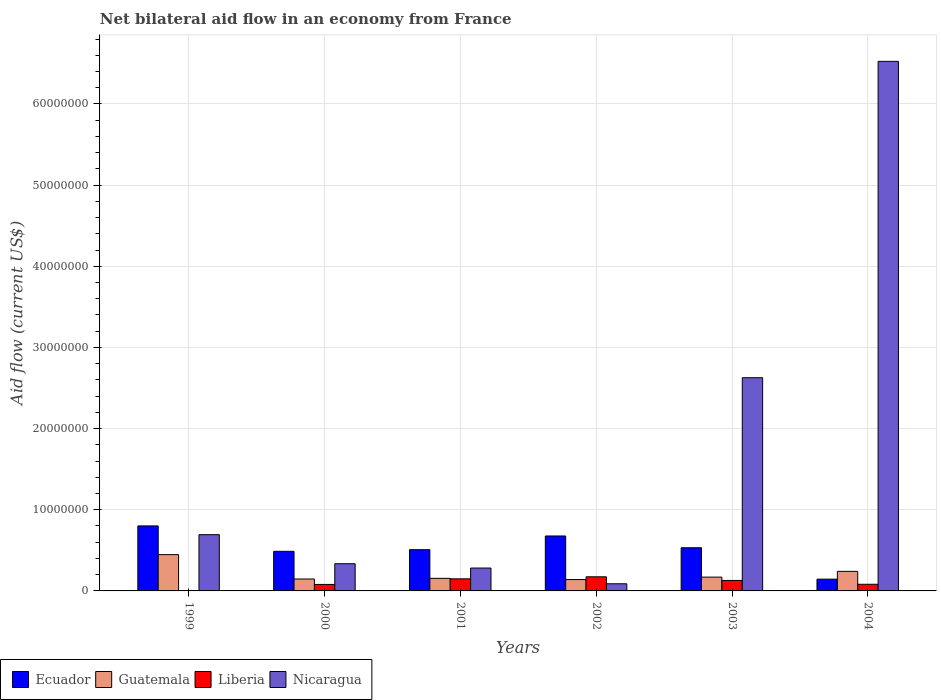How many groups of bars are there?
Your answer should be very brief. 6. Are the number of bars per tick equal to the number of legend labels?
Provide a succinct answer. Yes. In how many cases, is the number of bars for a given year not equal to the number of legend labels?
Give a very brief answer. 0. What is the net bilateral aid flow in Nicaragua in 2004?
Ensure brevity in your answer.  6.52e+07. Across all years, what is the maximum net bilateral aid flow in Ecuador?
Give a very brief answer. 8.01e+06. Across all years, what is the minimum net bilateral aid flow in Guatemala?
Keep it short and to the point. 1.40e+06. In which year was the net bilateral aid flow in Ecuador minimum?
Offer a very short reply. 2004. What is the total net bilateral aid flow in Guatemala in the graph?
Ensure brevity in your answer.  1.30e+07. What is the difference between the net bilateral aid flow in Ecuador in 2000 and that in 2003?
Your response must be concise. -4.40e+05. What is the difference between the net bilateral aid flow in Liberia in 2003 and the net bilateral aid flow in Ecuador in 2004?
Offer a very short reply. -1.60e+05. What is the average net bilateral aid flow in Ecuador per year?
Offer a terse response. 5.25e+06. What is the ratio of the net bilateral aid flow in Ecuador in 2001 to that in 2003?
Your answer should be very brief. 0.95. What is the difference between the highest and the second highest net bilateral aid flow in Guatemala?
Keep it short and to the point. 2.06e+06. What is the difference between the highest and the lowest net bilateral aid flow in Ecuador?
Your response must be concise. 6.56e+06. Is the sum of the net bilateral aid flow in Ecuador in 1999 and 2002 greater than the maximum net bilateral aid flow in Nicaragua across all years?
Your response must be concise. No. Is it the case that in every year, the sum of the net bilateral aid flow in Guatemala and net bilateral aid flow in Ecuador is greater than the sum of net bilateral aid flow in Liberia and net bilateral aid flow in Nicaragua?
Give a very brief answer. Yes. What does the 2nd bar from the left in 2003 represents?
Offer a very short reply. Guatemala. What does the 3rd bar from the right in 2003 represents?
Provide a short and direct response. Guatemala. Is it the case that in every year, the sum of the net bilateral aid flow in Nicaragua and net bilateral aid flow in Liberia is greater than the net bilateral aid flow in Ecuador?
Provide a short and direct response. No. How many bars are there?
Provide a succinct answer. 24. Are all the bars in the graph horizontal?
Make the answer very short. No. How many years are there in the graph?
Offer a very short reply. 6. What is the difference between two consecutive major ticks on the Y-axis?
Your answer should be very brief. 1.00e+07. Does the graph contain grids?
Offer a terse response. Yes. How are the legend labels stacked?
Offer a terse response. Horizontal. What is the title of the graph?
Keep it short and to the point. Net bilateral aid flow in an economy from France. What is the label or title of the Y-axis?
Keep it short and to the point. Aid flow (current US$). What is the Aid flow (current US$) of Ecuador in 1999?
Offer a very short reply. 8.01e+06. What is the Aid flow (current US$) in Guatemala in 1999?
Keep it short and to the point. 4.47e+06. What is the Aid flow (current US$) in Nicaragua in 1999?
Give a very brief answer. 6.93e+06. What is the Aid flow (current US$) in Ecuador in 2000?
Offer a terse response. 4.88e+06. What is the Aid flow (current US$) of Guatemala in 2000?
Your answer should be compact. 1.47e+06. What is the Aid flow (current US$) of Liberia in 2000?
Make the answer very short. 8.00e+05. What is the Aid flow (current US$) in Nicaragua in 2000?
Make the answer very short. 3.35e+06. What is the Aid flow (current US$) of Ecuador in 2001?
Make the answer very short. 5.08e+06. What is the Aid flow (current US$) of Guatemala in 2001?
Your answer should be very brief. 1.55e+06. What is the Aid flow (current US$) in Liberia in 2001?
Offer a very short reply. 1.49e+06. What is the Aid flow (current US$) in Nicaragua in 2001?
Give a very brief answer. 2.82e+06. What is the Aid flow (current US$) of Ecuador in 2002?
Ensure brevity in your answer.  6.77e+06. What is the Aid flow (current US$) in Guatemala in 2002?
Ensure brevity in your answer.  1.40e+06. What is the Aid flow (current US$) in Liberia in 2002?
Make the answer very short. 1.74e+06. What is the Aid flow (current US$) of Nicaragua in 2002?
Ensure brevity in your answer.  8.80e+05. What is the Aid flow (current US$) of Ecuador in 2003?
Ensure brevity in your answer.  5.32e+06. What is the Aid flow (current US$) in Guatemala in 2003?
Provide a short and direct response. 1.70e+06. What is the Aid flow (current US$) of Liberia in 2003?
Keep it short and to the point. 1.29e+06. What is the Aid flow (current US$) in Nicaragua in 2003?
Your answer should be compact. 2.63e+07. What is the Aid flow (current US$) in Ecuador in 2004?
Make the answer very short. 1.45e+06. What is the Aid flow (current US$) in Guatemala in 2004?
Offer a terse response. 2.41e+06. What is the Aid flow (current US$) in Liberia in 2004?
Your answer should be compact. 8.20e+05. What is the Aid flow (current US$) of Nicaragua in 2004?
Provide a succinct answer. 6.52e+07. Across all years, what is the maximum Aid flow (current US$) of Ecuador?
Offer a terse response. 8.01e+06. Across all years, what is the maximum Aid flow (current US$) of Guatemala?
Provide a succinct answer. 4.47e+06. Across all years, what is the maximum Aid flow (current US$) in Liberia?
Your answer should be very brief. 1.74e+06. Across all years, what is the maximum Aid flow (current US$) in Nicaragua?
Your response must be concise. 6.52e+07. Across all years, what is the minimum Aid flow (current US$) of Ecuador?
Ensure brevity in your answer.  1.45e+06. Across all years, what is the minimum Aid flow (current US$) in Guatemala?
Keep it short and to the point. 1.40e+06. Across all years, what is the minimum Aid flow (current US$) of Nicaragua?
Ensure brevity in your answer.  8.80e+05. What is the total Aid flow (current US$) in Ecuador in the graph?
Your response must be concise. 3.15e+07. What is the total Aid flow (current US$) of Guatemala in the graph?
Offer a very short reply. 1.30e+07. What is the total Aid flow (current US$) in Liberia in the graph?
Make the answer very short. 6.17e+06. What is the total Aid flow (current US$) in Nicaragua in the graph?
Ensure brevity in your answer.  1.06e+08. What is the difference between the Aid flow (current US$) in Ecuador in 1999 and that in 2000?
Keep it short and to the point. 3.13e+06. What is the difference between the Aid flow (current US$) in Guatemala in 1999 and that in 2000?
Give a very brief answer. 3.00e+06. What is the difference between the Aid flow (current US$) in Liberia in 1999 and that in 2000?
Give a very brief answer. -7.70e+05. What is the difference between the Aid flow (current US$) in Nicaragua in 1999 and that in 2000?
Your response must be concise. 3.58e+06. What is the difference between the Aid flow (current US$) in Ecuador in 1999 and that in 2001?
Offer a terse response. 2.93e+06. What is the difference between the Aid flow (current US$) in Guatemala in 1999 and that in 2001?
Your answer should be compact. 2.92e+06. What is the difference between the Aid flow (current US$) in Liberia in 1999 and that in 2001?
Your answer should be compact. -1.46e+06. What is the difference between the Aid flow (current US$) in Nicaragua in 1999 and that in 2001?
Offer a terse response. 4.11e+06. What is the difference between the Aid flow (current US$) in Ecuador in 1999 and that in 2002?
Give a very brief answer. 1.24e+06. What is the difference between the Aid flow (current US$) in Guatemala in 1999 and that in 2002?
Keep it short and to the point. 3.07e+06. What is the difference between the Aid flow (current US$) in Liberia in 1999 and that in 2002?
Keep it short and to the point. -1.71e+06. What is the difference between the Aid flow (current US$) in Nicaragua in 1999 and that in 2002?
Provide a succinct answer. 6.05e+06. What is the difference between the Aid flow (current US$) in Ecuador in 1999 and that in 2003?
Offer a terse response. 2.69e+06. What is the difference between the Aid flow (current US$) of Guatemala in 1999 and that in 2003?
Provide a succinct answer. 2.77e+06. What is the difference between the Aid flow (current US$) of Liberia in 1999 and that in 2003?
Ensure brevity in your answer.  -1.26e+06. What is the difference between the Aid flow (current US$) in Nicaragua in 1999 and that in 2003?
Your response must be concise. -1.93e+07. What is the difference between the Aid flow (current US$) of Ecuador in 1999 and that in 2004?
Provide a succinct answer. 6.56e+06. What is the difference between the Aid flow (current US$) of Guatemala in 1999 and that in 2004?
Keep it short and to the point. 2.06e+06. What is the difference between the Aid flow (current US$) in Liberia in 1999 and that in 2004?
Keep it short and to the point. -7.90e+05. What is the difference between the Aid flow (current US$) of Nicaragua in 1999 and that in 2004?
Offer a terse response. -5.83e+07. What is the difference between the Aid flow (current US$) of Guatemala in 2000 and that in 2001?
Offer a very short reply. -8.00e+04. What is the difference between the Aid flow (current US$) in Liberia in 2000 and that in 2001?
Ensure brevity in your answer.  -6.90e+05. What is the difference between the Aid flow (current US$) of Nicaragua in 2000 and that in 2001?
Offer a terse response. 5.30e+05. What is the difference between the Aid flow (current US$) of Ecuador in 2000 and that in 2002?
Ensure brevity in your answer.  -1.89e+06. What is the difference between the Aid flow (current US$) in Guatemala in 2000 and that in 2002?
Ensure brevity in your answer.  7.00e+04. What is the difference between the Aid flow (current US$) of Liberia in 2000 and that in 2002?
Make the answer very short. -9.40e+05. What is the difference between the Aid flow (current US$) of Nicaragua in 2000 and that in 2002?
Your response must be concise. 2.47e+06. What is the difference between the Aid flow (current US$) of Ecuador in 2000 and that in 2003?
Provide a succinct answer. -4.40e+05. What is the difference between the Aid flow (current US$) in Liberia in 2000 and that in 2003?
Keep it short and to the point. -4.90e+05. What is the difference between the Aid flow (current US$) in Nicaragua in 2000 and that in 2003?
Offer a very short reply. -2.29e+07. What is the difference between the Aid flow (current US$) in Ecuador in 2000 and that in 2004?
Your response must be concise. 3.43e+06. What is the difference between the Aid flow (current US$) in Guatemala in 2000 and that in 2004?
Your answer should be very brief. -9.40e+05. What is the difference between the Aid flow (current US$) in Nicaragua in 2000 and that in 2004?
Keep it short and to the point. -6.19e+07. What is the difference between the Aid flow (current US$) in Ecuador in 2001 and that in 2002?
Provide a succinct answer. -1.69e+06. What is the difference between the Aid flow (current US$) in Guatemala in 2001 and that in 2002?
Provide a succinct answer. 1.50e+05. What is the difference between the Aid flow (current US$) of Liberia in 2001 and that in 2002?
Provide a succinct answer. -2.50e+05. What is the difference between the Aid flow (current US$) of Nicaragua in 2001 and that in 2002?
Keep it short and to the point. 1.94e+06. What is the difference between the Aid flow (current US$) in Nicaragua in 2001 and that in 2003?
Offer a terse response. -2.34e+07. What is the difference between the Aid flow (current US$) of Ecuador in 2001 and that in 2004?
Give a very brief answer. 3.63e+06. What is the difference between the Aid flow (current US$) of Guatemala in 2001 and that in 2004?
Offer a terse response. -8.60e+05. What is the difference between the Aid flow (current US$) of Liberia in 2001 and that in 2004?
Your answer should be very brief. 6.70e+05. What is the difference between the Aid flow (current US$) of Nicaragua in 2001 and that in 2004?
Your response must be concise. -6.24e+07. What is the difference between the Aid flow (current US$) of Ecuador in 2002 and that in 2003?
Your response must be concise. 1.45e+06. What is the difference between the Aid flow (current US$) of Nicaragua in 2002 and that in 2003?
Provide a succinct answer. -2.54e+07. What is the difference between the Aid flow (current US$) of Ecuador in 2002 and that in 2004?
Keep it short and to the point. 5.32e+06. What is the difference between the Aid flow (current US$) of Guatemala in 2002 and that in 2004?
Provide a short and direct response. -1.01e+06. What is the difference between the Aid flow (current US$) in Liberia in 2002 and that in 2004?
Make the answer very short. 9.20e+05. What is the difference between the Aid flow (current US$) in Nicaragua in 2002 and that in 2004?
Your answer should be very brief. -6.44e+07. What is the difference between the Aid flow (current US$) of Ecuador in 2003 and that in 2004?
Give a very brief answer. 3.87e+06. What is the difference between the Aid flow (current US$) in Guatemala in 2003 and that in 2004?
Ensure brevity in your answer.  -7.10e+05. What is the difference between the Aid flow (current US$) in Liberia in 2003 and that in 2004?
Keep it short and to the point. 4.70e+05. What is the difference between the Aid flow (current US$) in Nicaragua in 2003 and that in 2004?
Your answer should be very brief. -3.90e+07. What is the difference between the Aid flow (current US$) in Ecuador in 1999 and the Aid flow (current US$) in Guatemala in 2000?
Your response must be concise. 6.54e+06. What is the difference between the Aid flow (current US$) of Ecuador in 1999 and the Aid flow (current US$) of Liberia in 2000?
Offer a terse response. 7.21e+06. What is the difference between the Aid flow (current US$) of Ecuador in 1999 and the Aid flow (current US$) of Nicaragua in 2000?
Ensure brevity in your answer.  4.66e+06. What is the difference between the Aid flow (current US$) in Guatemala in 1999 and the Aid flow (current US$) in Liberia in 2000?
Your answer should be very brief. 3.67e+06. What is the difference between the Aid flow (current US$) of Guatemala in 1999 and the Aid flow (current US$) of Nicaragua in 2000?
Provide a succinct answer. 1.12e+06. What is the difference between the Aid flow (current US$) of Liberia in 1999 and the Aid flow (current US$) of Nicaragua in 2000?
Keep it short and to the point. -3.32e+06. What is the difference between the Aid flow (current US$) in Ecuador in 1999 and the Aid flow (current US$) in Guatemala in 2001?
Offer a terse response. 6.46e+06. What is the difference between the Aid flow (current US$) of Ecuador in 1999 and the Aid flow (current US$) of Liberia in 2001?
Keep it short and to the point. 6.52e+06. What is the difference between the Aid flow (current US$) in Ecuador in 1999 and the Aid flow (current US$) in Nicaragua in 2001?
Ensure brevity in your answer.  5.19e+06. What is the difference between the Aid flow (current US$) of Guatemala in 1999 and the Aid flow (current US$) of Liberia in 2001?
Give a very brief answer. 2.98e+06. What is the difference between the Aid flow (current US$) of Guatemala in 1999 and the Aid flow (current US$) of Nicaragua in 2001?
Offer a terse response. 1.65e+06. What is the difference between the Aid flow (current US$) in Liberia in 1999 and the Aid flow (current US$) in Nicaragua in 2001?
Your answer should be very brief. -2.79e+06. What is the difference between the Aid flow (current US$) of Ecuador in 1999 and the Aid flow (current US$) of Guatemala in 2002?
Make the answer very short. 6.61e+06. What is the difference between the Aid flow (current US$) in Ecuador in 1999 and the Aid flow (current US$) in Liberia in 2002?
Provide a short and direct response. 6.27e+06. What is the difference between the Aid flow (current US$) in Ecuador in 1999 and the Aid flow (current US$) in Nicaragua in 2002?
Give a very brief answer. 7.13e+06. What is the difference between the Aid flow (current US$) of Guatemala in 1999 and the Aid flow (current US$) of Liberia in 2002?
Provide a short and direct response. 2.73e+06. What is the difference between the Aid flow (current US$) in Guatemala in 1999 and the Aid flow (current US$) in Nicaragua in 2002?
Make the answer very short. 3.59e+06. What is the difference between the Aid flow (current US$) in Liberia in 1999 and the Aid flow (current US$) in Nicaragua in 2002?
Make the answer very short. -8.50e+05. What is the difference between the Aid flow (current US$) in Ecuador in 1999 and the Aid flow (current US$) in Guatemala in 2003?
Give a very brief answer. 6.31e+06. What is the difference between the Aid flow (current US$) in Ecuador in 1999 and the Aid flow (current US$) in Liberia in 2003?
Give a very brief answer. 6.72e+06. What is the difference between the Aid flow (current US$) of Ecuador in 1999 and the Aid flow (current US$) of Nicaragua in 2003?
Ensure brevity in your answer.  -1.83e+07. What is the difference between the Aid flow (current US$) in Guatemala in 1999 and the Aid flow (current US$) in Liberia in 2003?
Provide a succinct answer. 3.18e+06. What is the difference between the Aid flow (current US$) of Guatemala in 1999 and the Aid flow (current US$) of Nicaragua in 2003?
Your response must be concise. -2.18e+07. What is the difference between the Aid flow (current US$) in Liberia in 1999 and the Aid flow (current US$) in Nicaragua in 2003?
Offer a very short reply. -2.62e+07. What is the difference between the Aid flow (current US$) in Ecuador in 1999 and the Aid flow (current US$) in Guatemala in 2004?
Offer a very short reply. 5.60e+06. What is the difference between the Aid flow (current US$) in Ecuador in 1999 and the Aid flow (current US$) in Liberia in 2004?
Your response must be concise. 7.19e+06. What is the difference between the Aid flow (current US$) of Ecuador in 1999 and the Aid flow (current US$) of Nicaragua in 2004?
Ensure brevity in your answer.  -5.72e+07. What is the difference between the Aid flow (current US$) in Guatemala in 1999 and the Aid flow (current US$) in Liberia in 2004?
Ensure brevity in your answer.  3.65e+06. What is the difference between the Aid flow (current US$) in Guatemala in 1999 and the Aid flow (current US$) in Nicaragua in 2004?
Ensure brevity in your answer.  -6.08e+07. What is the difference between the Aid flow (current US$) of Liberia in 1999 and the Aid flow (current US$) of Nicaragua in 2004?
Provide a short and direct response. -6.52e+07. What is the difference between the Aid flow (current US$) of Ecuador in 2000 and the Aid flow (current US$) of Guatemala in 2001?
Your response must be concise. 3.33e+06. What is the difference between the Aid flow (current US$) of Ecuador in 2000 and the Aid flow (current US$) of Liberia in 2001?
Provide a short and direct response. 3.39e+06. What is the difference between the Aid flow (current US$) of Ecuador in 2000 and the Aid flow (current US$) of Nicaragua in 2001?
Make the answer very short. 2.06e+06. What is the difference between the Aid flow (current US$) in Guatemala in 2000 and the Aid flow (current US$) in Liberia in 2001?
Provide a short and direct response. -2.00e+04. What is the difference between the Aid flow (current US$) of Guatemala in 2000 and the Aid flow (current US$) of Nicaragua in 2001?
Provide a succinct answer. -1.35e+06. What is the difference between the Aid flow (current US$) of Liberia in 2000 and the Aid flow (current US$) of Nicaragua in 2001?
Provide a short and direct response. -2.02e+06. What is the difference between the Aid flow (current US$) in Ecuador in 2000 and the Aid flow (current US$) in Guatemala in 2002?
Your answer should be compact. 3.48e+06. What is the difference between the Aid flow (current US$) of Ecuador in 2000 and the Aid flow (current US$) of Liberia in 2002?
Offer a terse response. 3.14e+06. What is the difference between the Aid flow (current US$) in Ecuador in 2000 and the Aid flow (current US$) in Nicaragua in 2002?
Your answer should be compact. 4.00e+06. What is the difference between the Aid flow (current US$) of Guatemala in 2000 and the Aid flow (current US$) of Nicaragua in 2002?
Give a very brief answer. 5.90e+05. What is the difference between the Aid flow (current US$) of Ecuador in 2000 and the Aid flow (current US$) of Guatemala in 2003?
Provide a succinct answer. 3.18e+06. What is the difference between the Aid flow (current US$) of Ecuador in 2000 and the Aid flow (current US$) of Liberia in 2003?
Your answer should be very brief. 3.59e+06. What is the difference between the Aid flow (current US$) of Ecuador in 2000 and the Aid flow (current US$) of Nicaragua in 2003?
Ensure brevity in your answer.  -2.14e+07. What is the difference between the Aid flow (current US$) in Guatemala in 2000 and the Aid flow (current US$) in Nicaragua in 2003?
Keep it short and to the point. -2.48e+07. What is the difference between the Aid flow (current US$) of Liberia in 2000 and the Aid flow (current US$) of Nicaragua in 2003?
Your response must be concise. -2.55e+07. What is the difference between the Aid flow (current US$) in Ecuador in 2000 and the Aid flow (current US$) in Guatemala in 2004?
Keep it short and to the point. 2.47e+06. What is the difference between the Aid flow (current US$) of Ecuador in 2000 and the Aid flow (current US$) of Liberia in 2004?
Make the answer very short. 4.06e+06. What is the difference between the Aid flow (current US$) in Ecuador in 2000 and the Aid flow (current US$) in Nicaragua in 2004?
Offer a terse response. -6.04e+07. What is the difference between the Aid flow (current US$) of Guatemala in 2000 and the Aid flow (current US$) of Liberia in 2004?
Make the answer very short. 6.50e+05. What is the difference between the Aid flow (current US$) in Guatemala in 2000 and the Aid flow (current US$) in Nicaragua in 2004?
Ensure brevity in your answer.  -6.38e+07. What is the difference between the Aid flow (current US$) of Liberia in 2000 and the Aid flow (current US$) of Nicaragua in 2004?
Your answer should be very brief. -6.44e+07. What is the difference between the Aid flow (current US$) of Ecuador in 2001 and the Aid flow (current US$) of Guatemala in 2002?
Offer a terse response. 3.68e+06. What is the difference between the Aid flow (current US$) in Ecuador in 2001 and the Aid flow (current US$) in Liberia in 2002?
Keep it short and to the point. 3.34e+06. What is the difference between the Aid flow (current US$) of Ecuador in 2001 and the Aid flow (current US$) of Nicaragua in 2002?
Your answer should be very brief. 4.20e+06. What is the difference between the Aid flow (current US$) in Guatemala in 2001 and the Aid flow (current US$) in Nicaragua in 2002?
Give a very brief answer. 6.70e+05. What is the difference between the Aid flow (current US$) in Ecuador in 2001 and the Aid flow (current US$) in Guatemala in 2003?
Provide a short and direct response. 3.38e+06. What is the difference between the Aid flow (current US$) in Ecuador in 2001 and the Aid flow (current US$) in Liberia in 2003?
Offer a terse response. 3.79e+06. What is the difference between the Aid flow (current US$) in Ecuador in 2001 and the Aid flow (current US$) in Nicaragua in 2003?
Your answer should be compact. -2.12e+07. What is the difference between the Aid flow (current US$) of Guatemala in 2001 and the Aid flow (current US$) of Liberia in 2003?
Offer a terse response. 2.60e+05. What is the difference between the Aid flow (current US$) of Guatemala in 2001 and the Aid flow (current US$) of Nicaragua in 2003?
Provide a succinct answer. -2.47e+07. What is the difference between the Aid flow (current US$) of Liberia in 2001 and the Aid flow (current US$) of Nicaragua in 2003?
Your answer should be very brief. -2.48e+07. What is the difference between the Aid flow (current US$) of Ecuador in 2001 and the Aid flow (current US$) of Guatemala in 2004?
Give a very brief answer. 2.67e+06. What is the difference between the Aid flow (current US$) of Ecuador in 2001 and the Aid flow (current US$) of Liberia in 2004?
Ensure brevity in your answer.  4.26e+06. What is the difference between the Aid flow (current US$) of Ecuador in 2001 and the Aid flow (current US$) of Nicaragua in 2004?
Give a very brief answer. -6.02e+07. What is the difference between the Aid flow (current US$) in Guatemala in 2001 and the Aid flow (current US$) in Liberia in 2004?
Provide a short and direct response. 7.30e+05. What is the difference between the Aid flow (current US$) of Guatemala in 2001 and the Aid flow (current US$) of Nicaragua in 2004?
Make the answer very short. -6.37e+07. What is the difference between the Aid flow (current US$) in Liberia in 2001 and the Aid flow (current US$) in Nicaragua in 2004?
Provide a short and direct response. -6.38e+07. What is the difference between the Aid flow (current US$) of Ecuador in 2002 and the Aid flow (current US$) of Guatemala in 2003?
Your answer should be very brief. 5.07e+06. What is the difference between the Aid flow (current US$) in Ecuador in 2002 and the Aid flow (current US$) in Liberia in 2003?
Make the answer very short. 5.48e+06. What is the difference between the Aid flow (current US$) of Ecuador in 2002 and the Aid flow (current US$) of Nicaragua in 2003?
Your response must be concise. -1.95e+07. What is the difference between the Aid flow (current US$) of Guatemala in 2002 and the Aid flow (current US$) of Liberia in 2003?
Give a very brief answer. 1.10e+05. What is the difference between the Aid flow (current US$) in Guatemala in 2002 and the Aid flow (current US$) in Nicaragua in 2003?
Your answer should be very brief. -2.49e+07. What is the difference between the Aid flow (current US$) in Liberia in 2002 and the Aid flow (current US$) in Nicaragua in 2003?
Offer a very short reply. -2.45e+07. What is the difference between the Aid flow (current US$) of Ecuador in 2002 and the Aid flow (current US$) of Guatemala in 2004?
Your answer should be very brief. 4.36e+06. What is the difference between the Aid flow (current US$) in Ecuador in 2002 and the Aid flow (current US$) in Liberia in 2004?
Give a very brief answer. 5.95e+06. What is the difference between the Aid flow (current US$) in Ecuador in 2002 and the Aid flow (current US$) in Nicaragua in 2004?
Offer a very short reply. -5.85e+07. What is the difference between the Aid flow (current US$) in Guatemala in 2002 and the Aid flow (current US$) in Liberia in 2004?
Provide a succinct answer. 5.80e+05. What is the difference between the Aid flow (current US$) of Guatemala in 2002 and the Aid flow (current US$) of Nicaragua in 2004?
Your answer should be compact. -6.38e+07. What is the difference between the Aid flow (current US$) of Liberia in 2002 and the Aid flow (current US$) of Nicaragua in 2004?
Offer a terse response. -6.35e+07. What is the difference between the Aid flow (current US$) in Ecuador in 2003 and the Aid flow (current US$) in Guatemala in 2004?
Make the answer very short. 2.91e+06. What is the difference between the Aid flow (current US$) in Ecuador in 2003 and the Aid flow (current US$) in Liberia in 2004?
Give a very brief answer. 4.50e+06. What is the difference between the Aid flow (current US$) in Ecuador in 2003 and the Aid flow (current US$) in Nicaragua in 2004?
Your answer should be very brief. -5.99e+07. What is the difference between the Aid flow (current US$) of Guatemala in 2003 and the Aid flow (current US$) of Liberia in 2004?
Offer a very short reply. 8.80e+05. What is the difference between the Aid flow (current US$) in Guatemala in 2003 and the Aid flow (current US$) in Nicaragua in 2004?
Provide a succinct answer. -6.36e+07. What is the difference between the Aid flow (current US$) in Liberia in 2003 and the Aid flow (current US$) in Nicaragua in 2004?
Ensure brevity in your answer.  -6.40e+07. What is the average Aid flow (current US$) of Ecuador per year?
Keep it short and to the point. 5.25e+06. What is the average Aid flow (current US$) in Guatemala per year?
Offer a very short reply. 2.17e+06. What is the average Aid flow (current US$) in Liberia per year?
Your response must be concise. 1.03e+06. What is the average Aid flow (current US$) of Nicaragua per year?
Provide a short and direct response. 1.76e+07. In the year 1999, what is the difference between the Aid flow (current US$) of Ecuador and Aid flow (current US$) of Guatemala?
Ensure brevity in your answer.  3.54e+06. In the year 1999, what is the difference between the Aid flow (current US$) of Ecuador and Aid flow (current US$) of Liberia?
Provide a succinct answer. 7.98e+06. In the year 1999, what is the difference between the Aid flow (current US$) of Ecuador and Aid flow (current US$) of Nicaragua?
Offer a very short reply. 1.08e+06. In the year 1999, what is the difference between the Aid flow (current US$) in Guatemala and Aid flow (current US$) in Liberia?
Your response must be concise. 4.44e+06. In the year 1999, what is the difference between the Aid flow (current US$) in Guatemala and Aid flow (current US$) in Nicaragua?
Offer a terse response. -2.46e+06. In the year 1999, what is the difference between the Aid flow (current US$) in Liberia and Aid flow (current US$) in Nicaragua?
Make the answer very short. -6.90e+06. In the year 2000, what is the difference between the Aid flow (current US$) of Ecuador and Aid flow (current US$) of Guatemala?
Keep it short and to the point. 3.41e+06. In the year 2000, what is the difference between the Aid flow (current US$) of Ecuador and Aid flow (current US$) of Liberia?
Provide a succinct answer. 4.08e+06. In the year 2000, what is the difference between the Aid flow (current US$) of Ecuador and Aid flow (current US$) of Nicaragua?
Offer a terse response. 1.53e+06. In the year 2000, what is the difference between the Aid flow (current US$) in Guatemala and Aid flow (current US$) in Liberia?
Ensure brevity in your answer.  6.70e+05. In the year 2000, what is the difference between the Aid flow (current US$) in Guatemala and Aid flow (current US$) in Nicaragua?
Keep it short and to the point. -1.88e+06. In the year 2000, what is the difference between the Aid flow (current US$) of Liberia and Aid flow (current US$) of Nicaragua?
Your response must be concise. -2.55e+06. In the year 2001, what is the difference between the Aid flow (current US$) in Ecuador and Aid flow (current US$) in Guatemala?
Your answer should be very brief. 3.53e+06. In the year 2001, what is the difference between the Aid flow (current US$) in Ecuador and Aid flow (current US$) in Liberia?
Keep it short and to the point. 3.59e+06. In the year 2001, what is the difference between the Aid flow (current US$) in Ecuador and Aid flow (current US$) in Nicaragua?
Make the answer very short. 2.26e+06. In the year 2001, what is the difference between the Aid flow (current US$) in Guatemala and Aid flow (current US$) in Nicaragua?
Your answer should be very brief. -1.27e+06. In the year 2001, what is the difference between the Aid flow (current US$) in Liberia and Aid flow (current US$) in Nicaragua?
Your answer should be compact. -1.33e+06. In the year 2002, what is the difference between the Aid flow (current US$) of Ecuador and Aid flow (current US$) of Guatemala?
Offer a terse response. 5.37e+06. In the year 2002, what is the difference between the Aid flow (current US$) in Ecuador and Aid flow (current US$) in Liberia?
Make the answer very short. 5.03e+06. In the year 2002, what is the difference between the Aid flow (current US$) in Ecuador and Aid flow (current US$) in Nicaragua?
Give a very brief answer. 5.89e+06. In the year 2002, what is the difference between the Aid flow (current US$) in Guatemala and Aid flow (current US$) in Liberia?
Ensure brevity in your answer.  -3.40e+05. In the year 2002, what is the difference between the Aid flow (current US$) in Guatemala and Aid flow (current US$) in Nicaragua?
Provide a short and direct response. 5.20e+05. In the year 2002, what is the difference between the Aid flow (current US$) in Liberia and Aid flow (current US$) in Nicaragua?
Provide a short and direct response. 8.60e+05. In the year 2003, what is the difference between the Aid flow (current US$) in Ecuador and Aid flow (current US$) in Guatemala?
Your response must be concise. 3.62e+06. In the year 2003, what is the difference between the Aid flow (current US$) in Ecuador and Aid flow (current US$) in Liberia?
Offer a terse response. 4.03e+06. In the year 2003, what is the difference between the Aid flow (current US$) of Ecuador and Aid flow (current US$) of Nicaragua?
Your answer should be compact. -2.10e+07. In the year 2003, what is the difference between the Aid flow (current US$) in Guatemala and Aid flow (current US$) in Nicaragua?
Ensure brevity in your answer.  -2.46e+07. In the year 2003, what is the difference between the Aid flow (current US$) of Liberia and Aid flow (current US$) of Nicaragua?
Your answer should be very brief. -2.50e+07. In the year 2004, what is the difference between the Aid flow (current US$) of Ecuador and Aid flow (current US$) of Guatemala?
Your answer should be compact. -9.60e+05. In the year 2004, what is the difference between the Aid flow (current US$) in Ecuador and Aid flow (current US$) in Liberia?
Provide a short and direct response. 6.30e+05. In the year 2004, what is the difference between the Aid flow (current US$) in Ecuador and Aid flow (current US$) in Nicaragua?
Give a very brief answer. -6.38e+07. In the year 2004, what is the difference between the Aid flow (current US$) of Guatemala and Aid flow (current US$) of Liberia?
Your answer should be very brief. 1.59e+06. In the year 2004, what is the difference between the Aid flow (current US$) of Guatemala and Aid flow (current US$) of Nicaragua?
Give a very brief answer. -6.28e+07. In the year 2004, what is the difference between the Aid flow (current US$) of Liberia and Aid flow (current US$) of Nicaragua?
Your answer should be very brief. -6.44e+07. What is the ratio of the Aid flow (current US$) of Ecuador in 1999 to that in 2000?
Give a very brief answer. 1.64. What is the ratio of the Aid flow (current US$) of Guatemala in 1999 to that in 2000?
Make the answer very short. 3.04. What is the ratio of the Aid flow (current US$) in Liberia in 1999 to that in 2000?
Give a very brief answer. 0.04. What is the ratio of the Aid flow (current US$) of Nicaragua in 1999 to that in 2000?
Provide a succinct answer. 2.07. What is the ratio of the Aid flow (current US$) in Ecuador in 1999 to that in 2001?
Your answer should be very brief. 1.58. What is the ratio of the Aid flow (current US$) in Guatemala in 1999 to that in 2001?
Your answer should be compact. 2.88. What is the ratio of the Aid flow (current US$) in Liberia in 1999 to that in 2001?
Your response must be concise. 0.02. What is the ratio of the Aid flow (current US$) in Nicaragua in 1999 to that in 2001?
Provide a succinct answer. 2.46. What is the ratio of the Aid flow (current US$) in Ecuador in 1999 to that in 2002?
Offer a terse response. 1.18. What is the ratio of the Aid flow (current US$) in Guatemala in 1999 to that in 2002?
Provide a succinct answer. 3.19. What is the ratio of the Aid flow (current US$) in Liberia in 1999 to that in 2002?
Provide a short and direct response. 0.02. What is the ratio of the Aid flow (current US$) of Nicaragua in 1999 to that in 2002?
Your answer should be compact. 7.88. What is the ratio of the Aid flow (current US$) of Ecuador in 1999 to that in 2003?
Provide a succinct answer. 1.51. What is the ratio of the Aid flow (current US$) of Guatemala in 1999 to that in 2003?
Your answer should be compact. 2.63. What is the ratio of the Aid flow (current US$) in Liberia in 1999 to that in 2003?
Keep it short and to the point. 0.02. What is the ratio of the Aid flow (current US$) in Nicaragua in 1999 to that in 2003?
Offer a terse response. 0.26. What is the ratio of the Aid flow (current US$) in Ecuador in 1999 to that in 2004?
Your answer should be very brief. 5.52. What is the ratio of the Aid flow (current US$) of Guatemala in 1999 to that in 2004?
Make the answer very short. 1.85. What is the ratio of the Aid flow (current US$) of Liberia in 1999 to that in 2004?
Offer a very short reply. 0.04. What is the ratio of the Aid flow (current US$) of Nicaragua in 1999 to that in 2004?
Your answer should be very brief. 0.11. What is the ratio of the Aid flow (current US$) of Ecuador in 2000 to that in 2001?
Ensure brevity in your answer.  0.96. What is the ratio of the Aid flow (current US$) in Guatemala in 2000 to that in 2001?
Your answer should be very brief. 0.95. What is the ratio of the Aid flow (current US$) of Liberia in 2000 to that in 2001?
Your response must be concise. 0.54. What is the ratio of the Aid flow (current US$) of Nicaragua in 2000 to that in 2001?
Provide a short and direct response. 1.19. What is the ratio of the Aid flow (current US$) of Ecuador in 2000 to that in 2002?
Keep it short and to the point. 0.72. What is the ratio of the Aid flow (current US$) in Liberia in 2000 to that in 2002?
Your answer should be very brief. 0.46. What is the ratio of the Aid flow (current US$) in Nicaragua in 2000 to that in 2002?
Provide a short and direct response. 3.81. What is the ratio of the Aid flow (current US$) in Ecuador in 2000 to that in 2003?
Make the answer very short. 0.92. What is the ratio of the Aid flow (current US$) in Guatemala in 2000 to that in 2003?
Give a very brief answer. 0.86. What is the ratio of the Aid flow (current US$) of Liberia in 2000 to that in 2003?
Give a very brief answer. 0.62. What is the ratio of the Aid flow (current US$) of Nicaragua in 2000 to that in 2003?
Offer a very short reply. 0.13. What is the ratio of the Aid flow (current US$) of Ecuador in 2000 to that in 2004?
Give a very brief answer. 3.37. What is the ratio of the Aid flow (current US$) of Guatemala in 2000 to that in 2004?
Make the answer very short. 0.61. What is the ratio of the Aid flow (current US$) of Liberia in 2000 to that in 2004?
Offer a very short reply. 0.98. What is the ratio of the Aid flow (current US$) of Nicaragua in 2000 to that in 2004?
Ensure brevity in your answer.  0.05. What is the ratio of the Aid flow (current US$) in Ecuador in 2001 to that in 2002?
Provide a succinct answer. 0.75. What is the ratio of the Aid flow (current US$) in Guatemala in 2001 to that in 2002?
Make the answer very short. 1.11. What is the ratio of the Aid flow (current US$) in Liberia in 2001 to that in 2002?
Ensure brevity in your answer.  0.86. What is the ratio of the Aid flow (current US$) in Nicaragua in 2001 to that in 2002?
Provide a succinct answer. 3.2. What is the ratio of the Aid flow (current US$) in Ecuador in 2001 to that in 2003?
Offer a terse response. 0.95. What is the ratio of the Aid flow (current US$) of Guatemala in 2001 to that in 2003?
Make the answer very short. 0.91. What is the ratio of the Aid flow (current US$) in Liberia in 2001 to that in 2003?
Provide a short and direct response. 1.16. What is the ratio of the Aid flow (current US$) of Nicaragua in 2001 to that in 2003?
Ensure brevity in your answer.  0.11. What is the ratio of the Aid flow (current US$) in Ecuador in 2001 to that in 2004?
Provide a succinct answer. 3.5. What is the ratio of the Aid flow (current US$) of Guatemala in 2001 to that in 2004?
Give a very brief answer. 0.64. What is the ratio of the Aid flow (current US$) in Liberia in 2001 to that in 2004?
Your response must be concise. 1.82. What is the ratio of the Aid flow (current US$) of Nicaragua in 2001 to that in 2004?
Offer a very short reply. 0.04. What is the ratio of the Aid flow (current US$) of Ecuador in 2002 to that in 2003?
Offer a very short reply. 1.27. What is the ratio of the Aid flow (current US$) of Guatemala in 2002 to that in 2003?
Provide a short and direct response. 0.82. What is the ratio of the Aid flow (current US$) of Liberia in 2002 to that in 2003?
Make the answer very short. 1.35. What is the ratio of the Aid flow (current US$) in Nicaragua in 2002 to that in 2003?
Your answer should be compact. 0.03. What is the ratio of the Aid flow (current US$) of Ecuador in 2002 to that in 2004?
Your answer should be very brief. 4.67. What is the ratio of the Aid flow (current US$) of Guatemala in 2002 to that in 2004?
Offer a terse response. 0.58. What is the ratio of the Aid flow (current US$) in Liberia in 2002 to that in 2004?
Keep it short and to the point. 2.12. What is the ratio of the Aid flow (current US$) in Nicaragua in 2002 to that in 2004?
Provide a short and direct response. 0.01. What is the ratio of the Aid flow (current US$) in Ecuador in 2003 to that in 2004?
Provide a short and direct response. 3.67. What is the ratio of the Aid flow (current US$) of Guatemala in 2003 to that in 2004?
Keep it short and to the point. 0.71. What is the ratio of the Aid flow (current US$) in Liberia in 2003 to that in 2004?
Provide a succinct answer. 1.57. What is the ratio of the Aid flow (current US$) of Nicaragua in 2003 to that in 2004?
Offer a terse response. 0.4. What is the difference between the highest and the second highest Aid flow (current US$) in Ecuador?
Your response must be concise. 1.24e+06. What is the difference between the highest and the second highest Aid flow (current US$) of Guatemala?
Your answer should be very brief. 2.06e+06. What is the difference between the highest and the second highest Aid flow (current US$) in Nicaragua?
Provide a succinct answer. 3.90e+07. What is the difference between the highest and the lowest Aid flow (current US$) of Ecuador?
Offer a very short reply. 6.56e+06. What is the difference between the highest and the lowest Aid flow (current US$) in Guatemala?
Provide a short and direct response. 3.07e+06. What is the difference between the highest and the lowest Aid flow (current US$) in Liberia?
Your response must be concise. 1.71e+06. What is the difference between the highest and the lowest Aid flow (current US$) of Nicaragua?
Make the answer very short. 6.44e+07. 